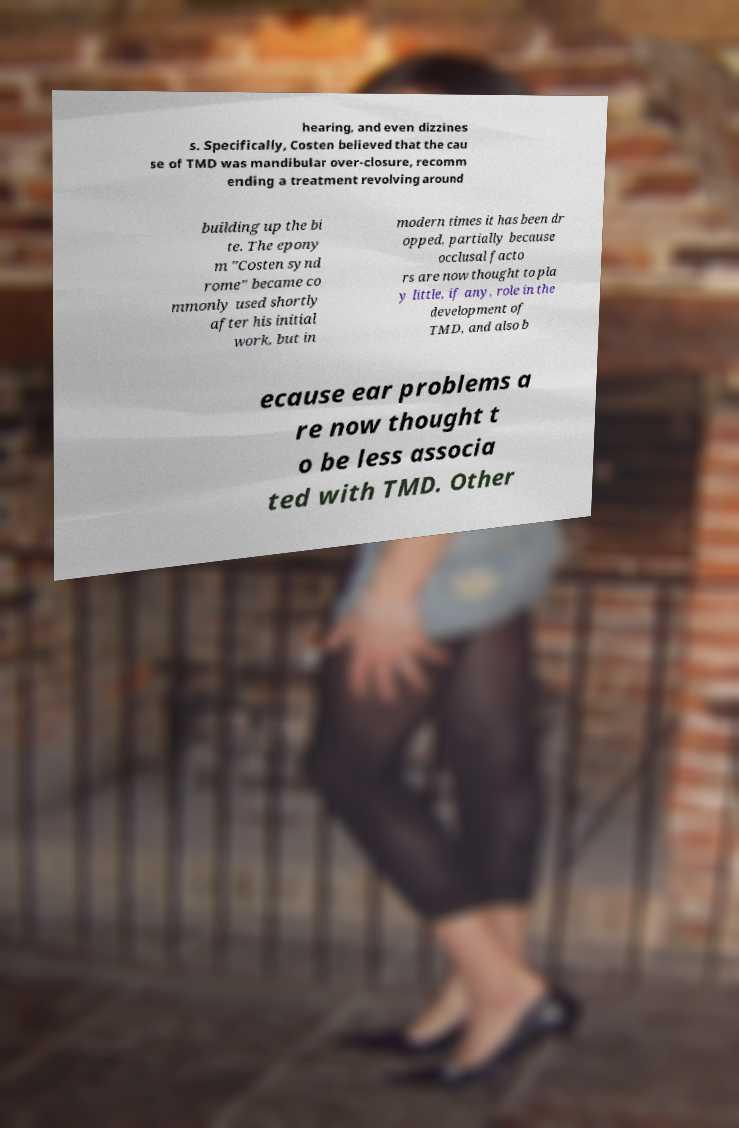Could you extract and type out the text from this image? hearing, and even dizzines s. Specifically, Costen believed that the cau se of TMD was mandibular over-closure, recomm ending a treatment revolving around building up the bi te. The epony m "Costen synd rome" became co mmonly used shortly after his initial work, but in modern times it has been dr opped, partially because occlusal facto rs are now thought to pla y little, if any, role in the development of TMD, and also b ecause ear problems a re now thought t o be less associa ted with TMD. Other 